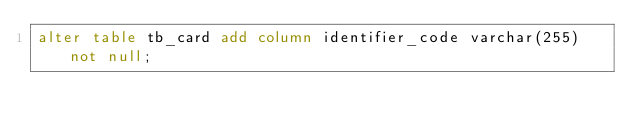<code> <loc_0><loc_0><loc_500><loc_500><_SQL_>alter table tb_card add column identifier_code varchar(255) not null;</code> 